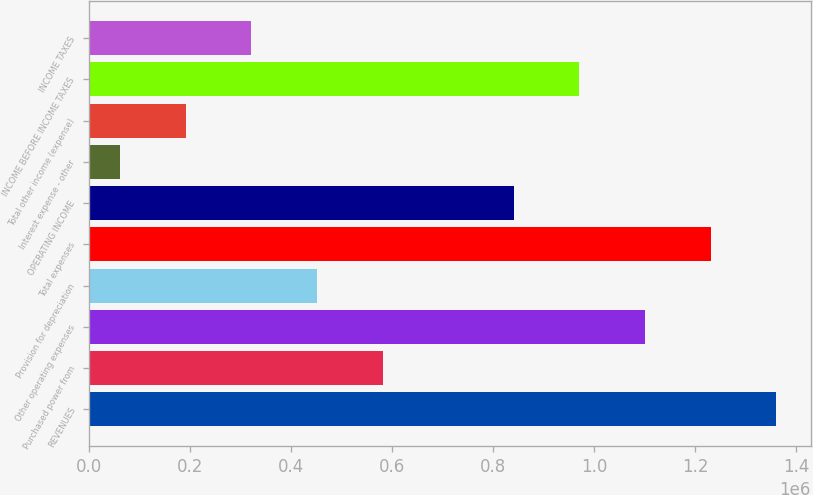Convert chart to OTSL. <chart><loc_0><loc_0><loc_500><loc_500><bar_chart><fcel>REVENUES<fcel>Purchased power from<fcel>Other operating expenses<fcel>Provision for depreciation<fcel>Total expenses<fcel>OPERATING INCOME<fcel>Interest expense - other<fcel>Total other income (expense)<fcel>INCOME BEFORE INCOME TAXES<fcel>INCOME TAXES<nl><fcel>1.36052e+06<fcel>581429<fcel>1.10082e+06<fcel>451580<fcel>1.23067e+06<fcel>841127<fcel>62034<fcel>191883<fcel>970976<fcel>321732<nl></chart> 